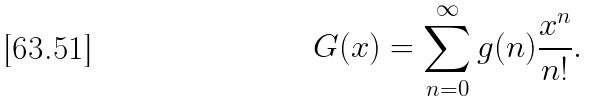<formula> <loc_0><loc_0><loc_500><loc_500>G ( x ) = \sum _ { n = 0 } ^ { \infty } g ( n ) \frac { x ^ { n } } { n ! } .</formula> 